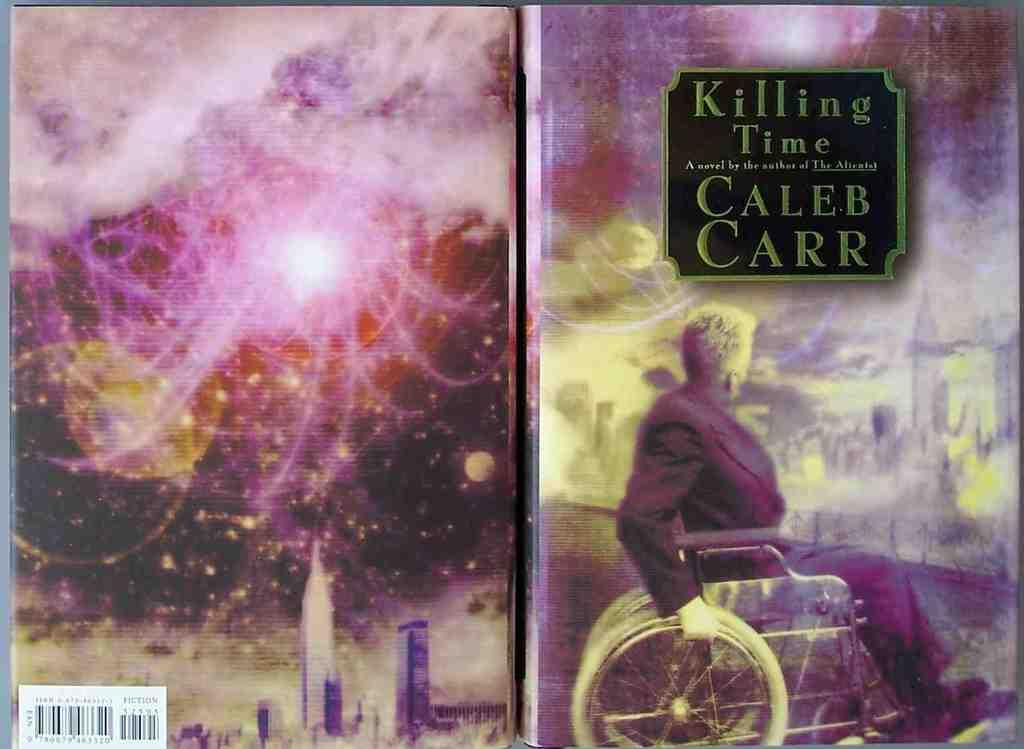<image>
Share a concise interpretation of the image provided. The front and back cover of a book called Killing Time shows a man in a wheelchair. 